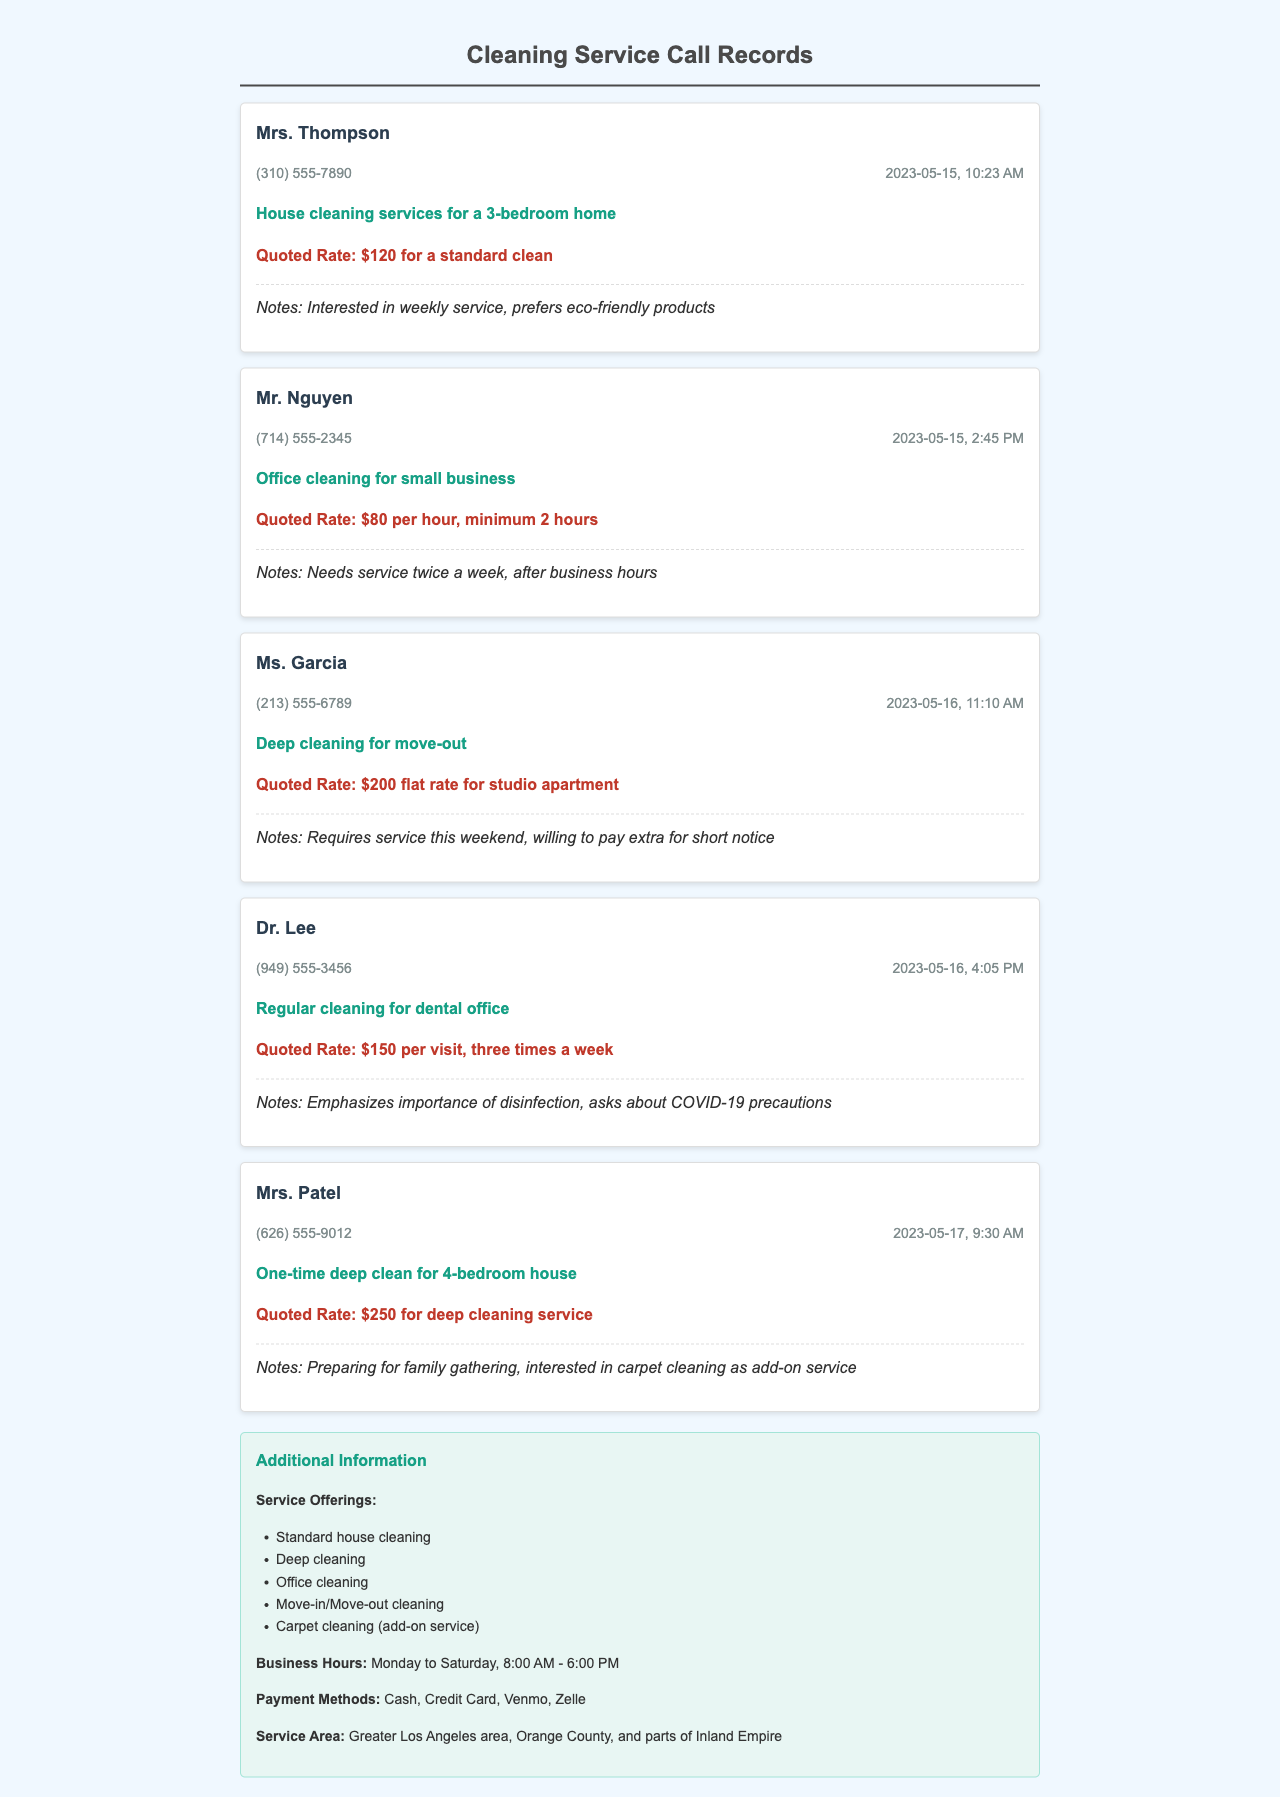What is the name of the first client? The first client mentioned in the document is Mrs. Thompson.
Answer: Mrs. Thompson How much is the quoted rate for deep cleaning of a studio apartment? The quoted rate for deep cleaning a studio apartment is stated in Ms. Garcia's record.
Answer: $200 flat rate When did Dr. Lee call? The date and time of Dr. Lee's call are noted in the call record.
Answer: 2023-05-16, 4:05 PM How many times a week does Dr. Lee require cleaning service? The document specifies how often Dr. Lee needs the cleaning service in the notes section.
Answer: three times a week What type of cleaning service does Mr. Nguyen inquire about? Mr. Nguyen's inquiry details are provided in his call record.
Answer: Office cleaning for small business What is the additional service Mrs. Patel is interested in? The call record for Mrs. Patel mentions her interest in an additional service.
Answer: Carpet cleaning Which payment methods are accepted? The payment methods are listed in the additional information section of the document.
Answer: Cash, Credit Card, Venmo, Zelle What is the minimum hours Mr. Nguyen requires for service? The minimum hours required for Mr. Nguyen's service are specified in his call record.
Answer: minimum 2 hours What is the service area mentioned in the document? The document specifies the service area in the additional information.
Answer: Greater Los Angeles area, Orange County, and parts of Inland Empire 